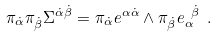Convert formula to latex. <formula><loc_0><loc_0><loc_500><loc_500>\pi _ { \dot { \alpha } } \pi _ { \dot { \beta } } \Sigma ^ { \dot { \alpha } \dot { \beta } } = \pi _ { \dot { \alpha } } e ^ { \alpha \dot { \alpha } } \wedge \pi _ { \dot { \beta } } e _ { \alpha } ^ { \ \dot { \beta } } \ .</formula> 